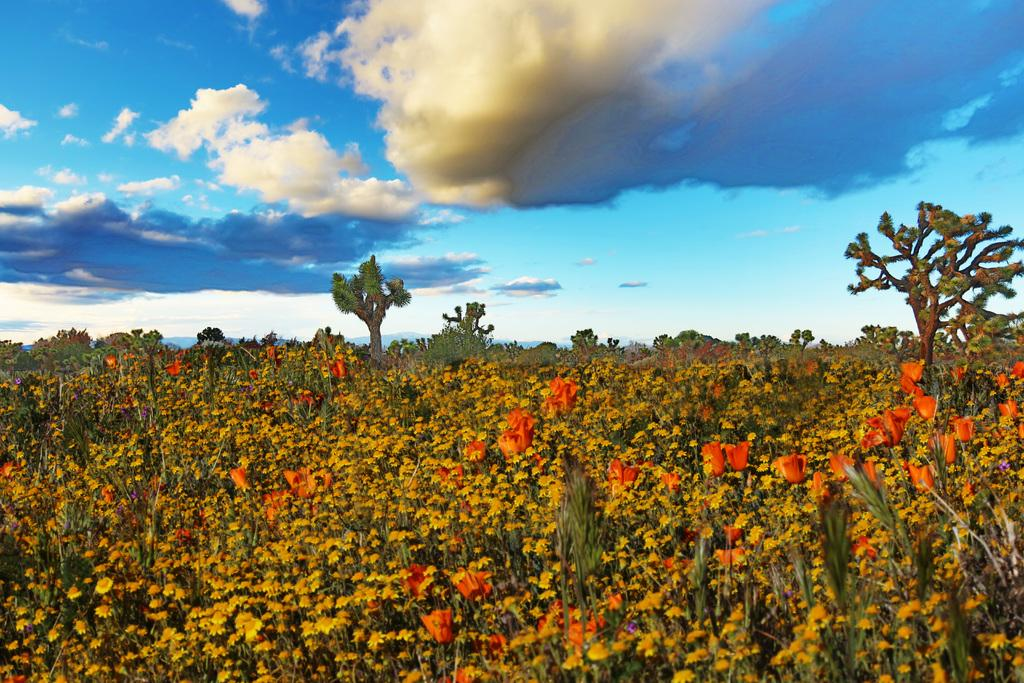What type of image is being described? The image is an animated picture. What can be seen in the foreground of the image? There are plants and flowers in the foreground of the image. What is located in the center of the image? There are trees and plants in the center of the image. How would you describe the sky in the image? The sky is cloudy. Reasoning: Let's think step by step by step in order to produce the conversation. We start by identifying the nature of the image, which is an animated picture. Then, we describe the elements in the foreground and center of the image, focusing on the plants and trees. Finally, we mention the sky's condition, which is cloudy. Each question is designed to elicit a specific detail about the image that is known from the provided facts. Absurd Question/Answer: What type of chain can be seen hanging from the tree in the image? There is no chain present in the image; it features plants, flowers, trees, and a cloudy sky. Can you tell me how many tubs of soda are visible in the image? There are no tubs or soda present in the image. What type of chain can be seen hanging from the tree in the image? There is no chain present in the image; it features plants, flowers, trees, and a cloudy sky. Can you tell me how many tubs of soda are visible in the image? There are no tubs or soda present in the image. 